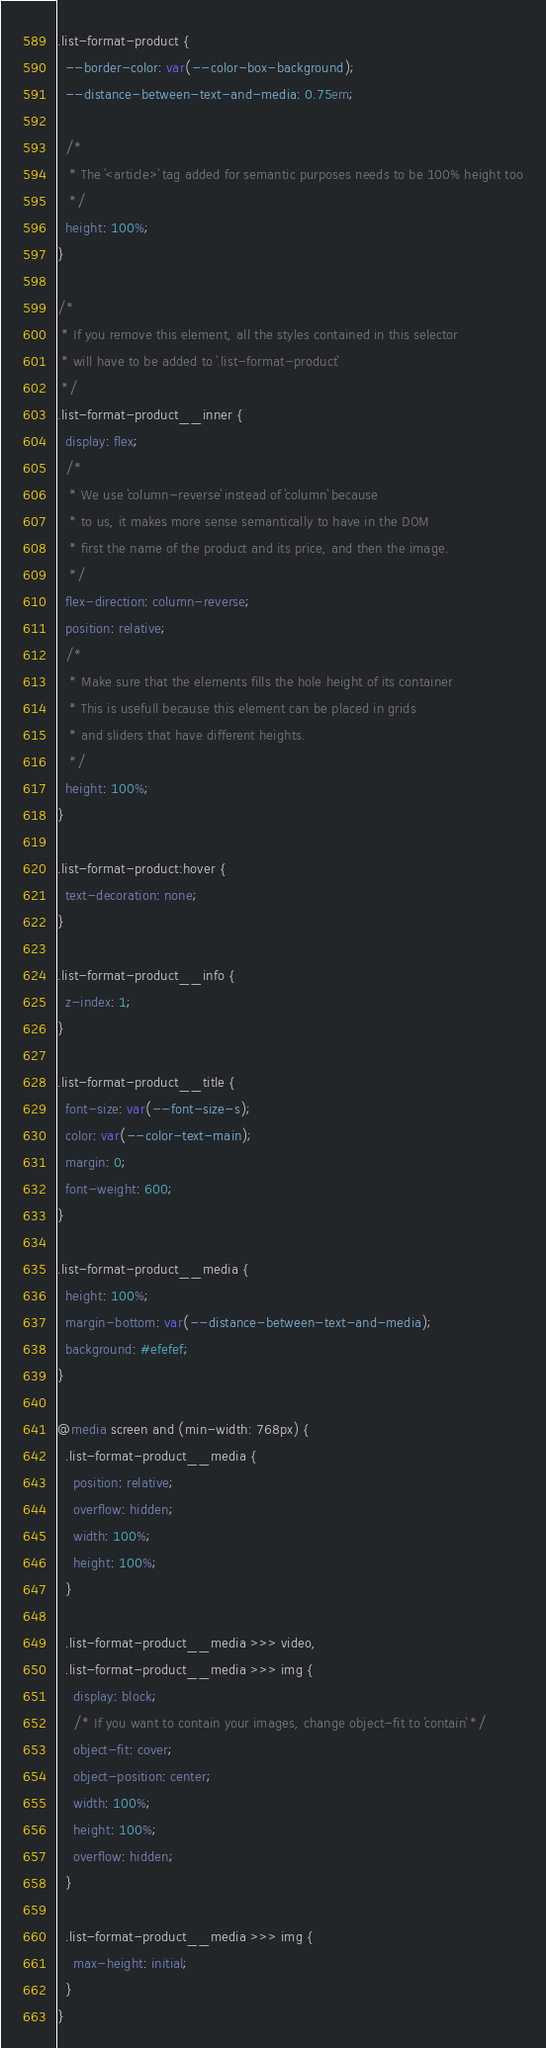<code> <loc_0><loc_0><loc_500><loc_500><_CSS_>.list-format-product {
  --border-color: var(--color-box-background);
  --distance-between-text-and-media: 0.75em;
  
  /*
   * The `<article>` tag added for semantic purposes needs to be 100% height too
   */
  height: 100%;
}

/*
 * If you remove this element, all the styles contained in this selector
 * will have to be added to `.list-format-product`
 */
.list-format-product__inner {
  display: flex;
  /*
   * We use `column-reverse` instead of `column` because
   * to us, it makes more sense semantically to have in the DOM
   * first the name of the product and its price, and then the image.
   */
  flex-direction: column-reverse;
  position: relative;
  /*
   * Make sure that the elements fills the hole height of its container
   * This is usefull because this element can be placed in grids
   * and sliders that have different heights.
   */
  height: 100%;
}

.list-format-product:hover {
  text-decoration: none;
}

.list-format-product__info {
  z-index: 1;
}

.list-format-product__title {
  font-size: var(--font-size-s);
  color: var(--color-text-main);
  margin: 0;
  font-weight: 600;
}

.list-format-product__media {
  height: 100%;
  margin-bottom: var(--distance-between-text-and-media);
  background: #efefef;
}

@media screen and (min-width: 768px) {
  .list-format-product__media {
    position: relative;
    overflow: hidden;
    width: 100%;
    height: 100%;
  }

  .list-format-product__media >>> video,
  .list-format-product__media >>> img {
    display: block;
    /* If you want to contain your images, change object-fit to `contain` */
    object-fit: cover;
    object-position: center;
    width: 100%;
    height: 100%;
    overflow: hidden;
  }

  .list-format-product__media >>> img {
    max-height: initial;
  }
}</code> 